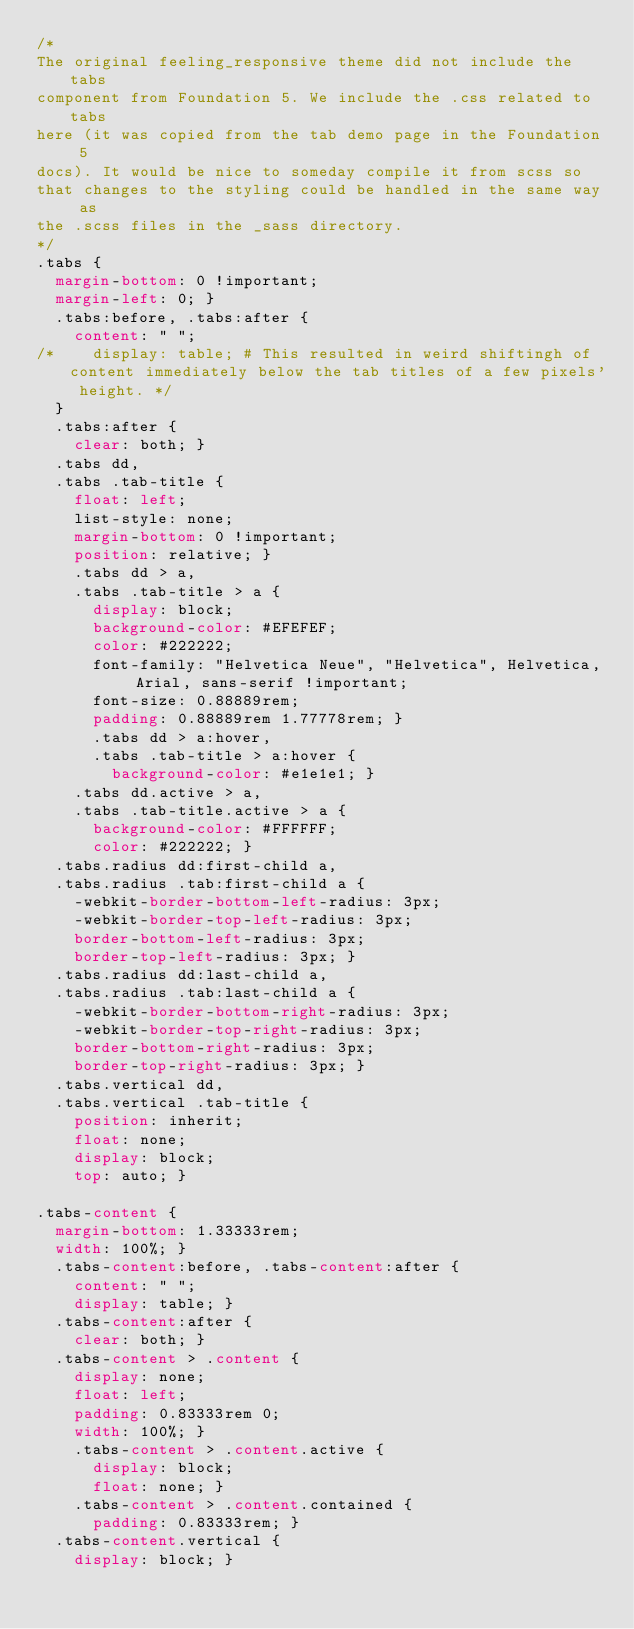Convert code to text. <code><loc_0><loc_0><loc_500><loc_500><_CSS_>/*
The original feeling_responsive theme did not include the tabs
component from Foundation 5. We include the .css related to tabs
here (it was copied from the tab demo page in the Foundation 5
docs). It would be nice to someday compile it from scss so
that changes to the styling could be handled in the same way as
the .scss files in the _sass directory.
*/
.tabs {
  margin-bottom: 0 !important;
  margin-left: 0; }
  .tabs:before, .tabs:after {
    content: " ";
/*    display: table; # This resulted in weird shiftingh of content immediately below the tab titles of a few pixels' height. */
  }
  .tabs:after {
    clear: both; }
  .tabs dd,
  .tabs .tab-title {
    float: left;
    list-style: none;
    margin-bottom: 0 !important;
    position: relative; }
    .tabs dd > a,
    .tabs .tab-title > a {
      display: block;
      background-color: #EFEFEF;
      color: #222222;
      font-family: "Helvetica Neue", "Helvetica", Helvetica, Arial, sans-serif !important;
      font-size: 0.88889rem;
      padding: 0.88889rem 1.77778rem; }
      .tabs dd > a:hover,
      .tabs .tab-title > a:hover {
        background-color: #e1e1e1; }
    .tabs dd.active > a,
    .tabs .tab-title.active > a {
      background-color: #FFFFFF;
      color: #222222; }
  .tabs.radius dd:first-child a,
  .tabs.radius .tab:first-child a {
    -webkit-border-bottom-left-radius: 3px;
    -webkit-border-top-left-radius: 3px;
    border-bottom-left-radius: 3px;
    border-top-left-radius: 3px; }
  .tabs.radius dd:last-child a,
  .tabs.radius .tab:last-child a {
    -webkit-border-bottom-right-radius: 3px;
    -webkit-border-top-right-radius: 3px;
    border-bottom-right-radius: 3px;
    border-top-right-radius: 3px; }
  .tabs.vertical dd,
  .tabs.vertical .tab-title {
    position: inherit;
    float: none;
    display: block;
    top: auto; }

.tabs-content {
  margin-bottom: 1.33333rem;
  width: 100%; }
  .tabs-content:before, .tabs-content:after {
    content: " ";
    display: table; }
  .tabs-content:after {
    clear: both; }
  .tabs-content > .content {
    display: none;
    float: left;
    padding: 0.83333rem 0;
    width: 100%; }
    .tabs-content > .content.active {
      display: block;
      float: none; }
    .tabs-content > .content.contained {
      padding: 0.83333rem; }
  .tabs-content.vertical {
    display: block; }</code> 